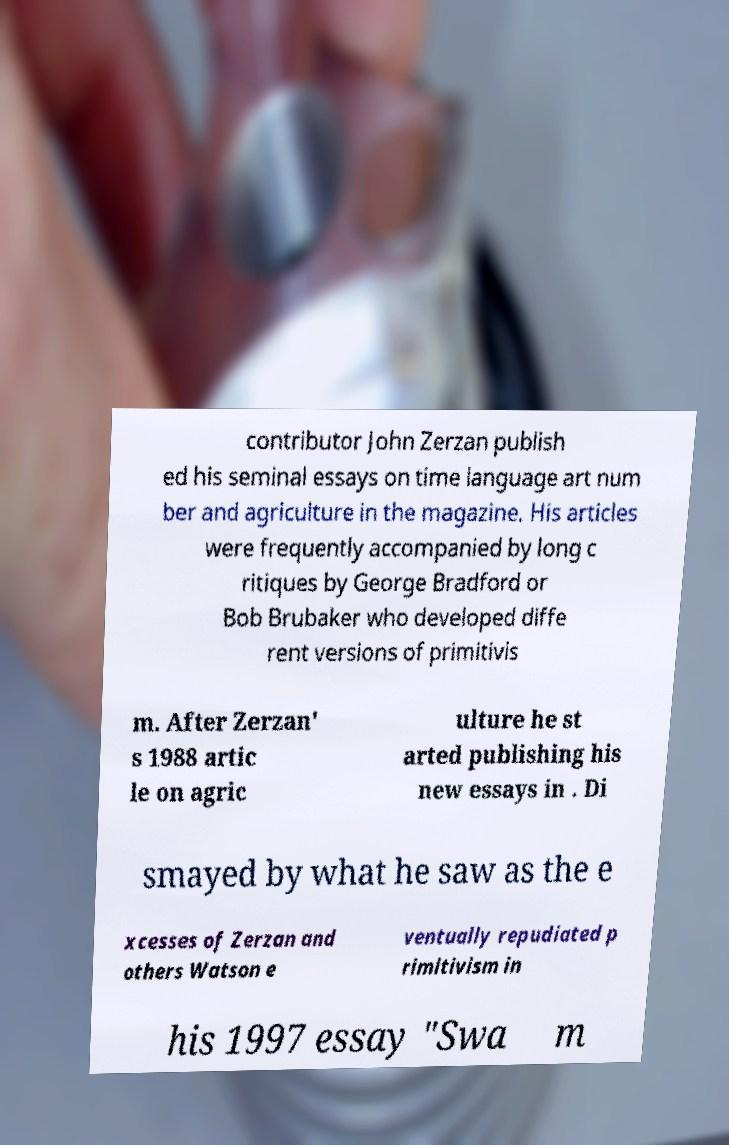Can you read and provide the text displayed in the image?This photo seems to have some interesting text. Can you extract and type it out for me? contributor John Zerzan publish ed his seminal essays on time language art num ber and agriculture in the magazine. His articles were frequently accompanied by long c ritiques by George Bradford or Bob Brubaker who developed diffe rent versions of primitivis m. After Zerzan' s 1988 artic le on agric ulture he st arted publishing his new essays in . Di smayed by what he saw as the e xcesses of Zerzan and others Watson e ventually repudiated p rimitivism in his 1997 essay "Swa m 